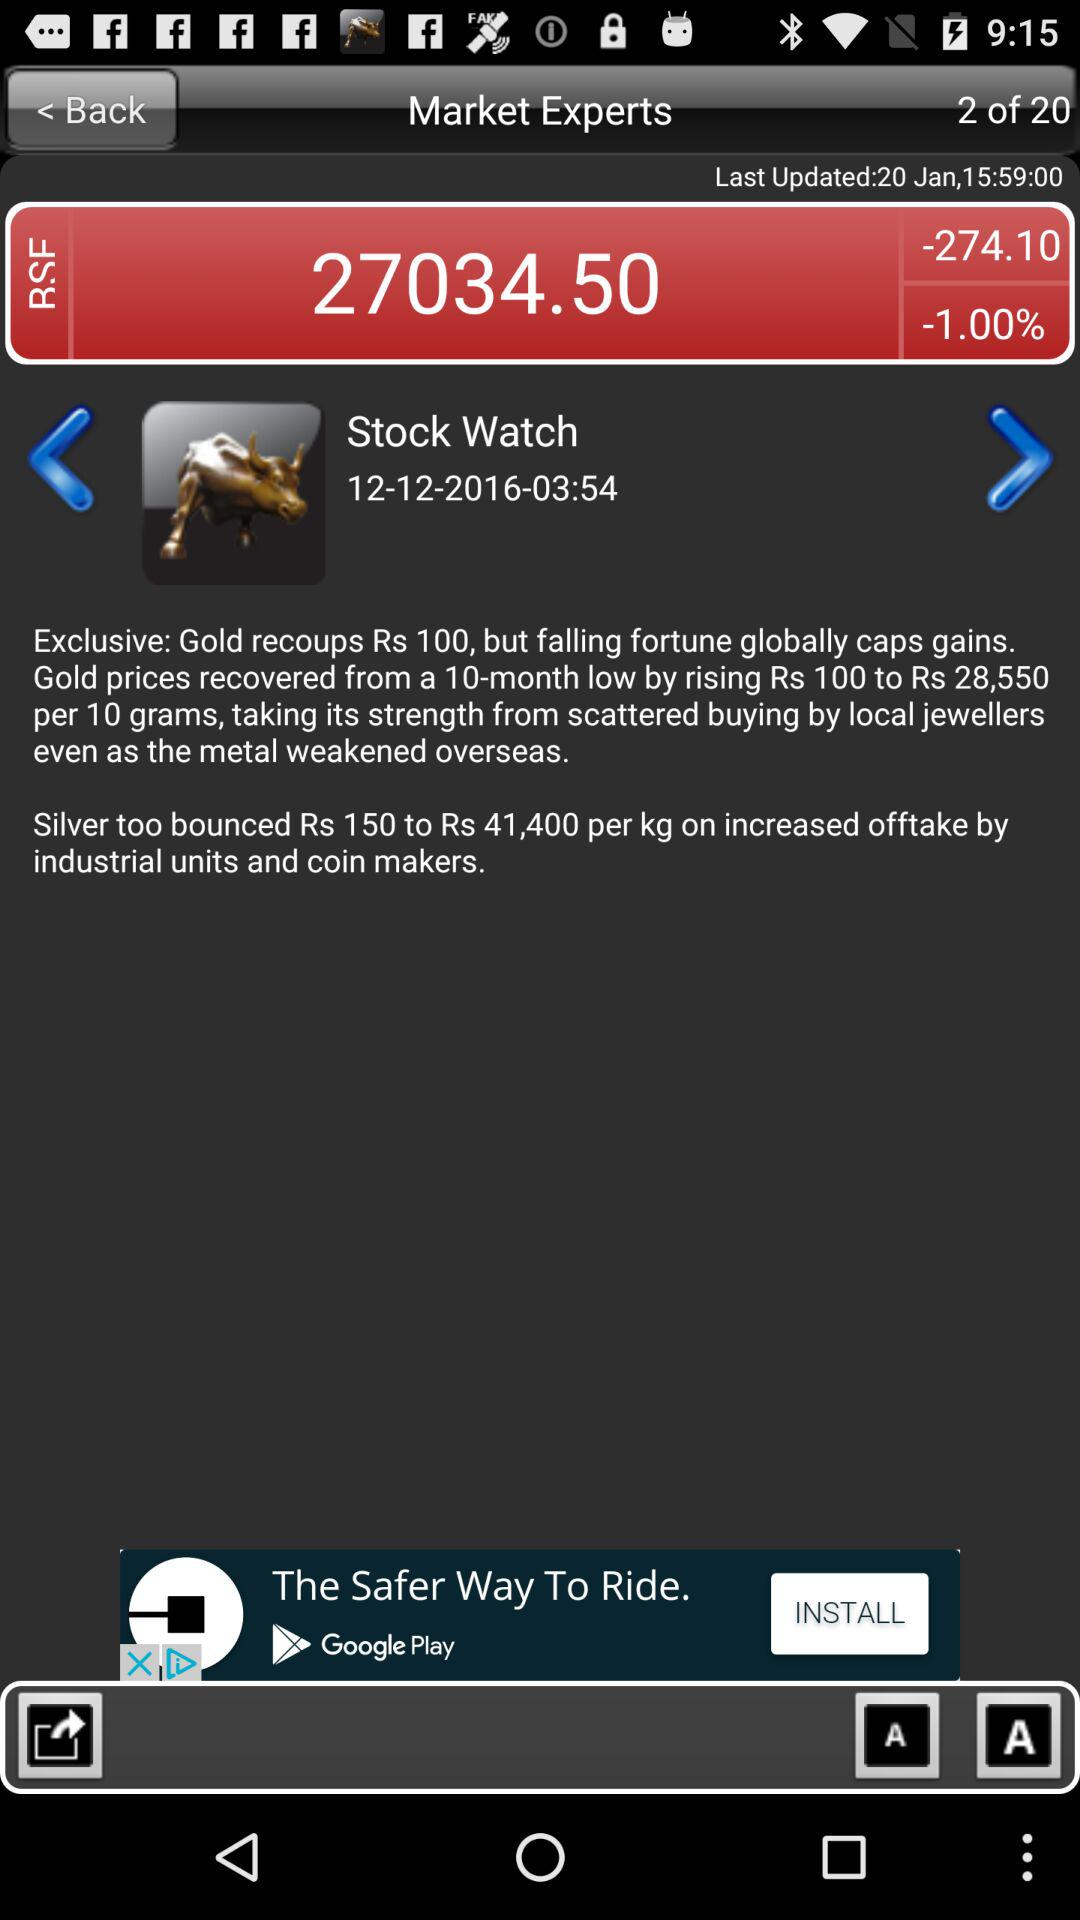What is the price of gold? The price of gold is Rs 28,550 per 10 grams. 